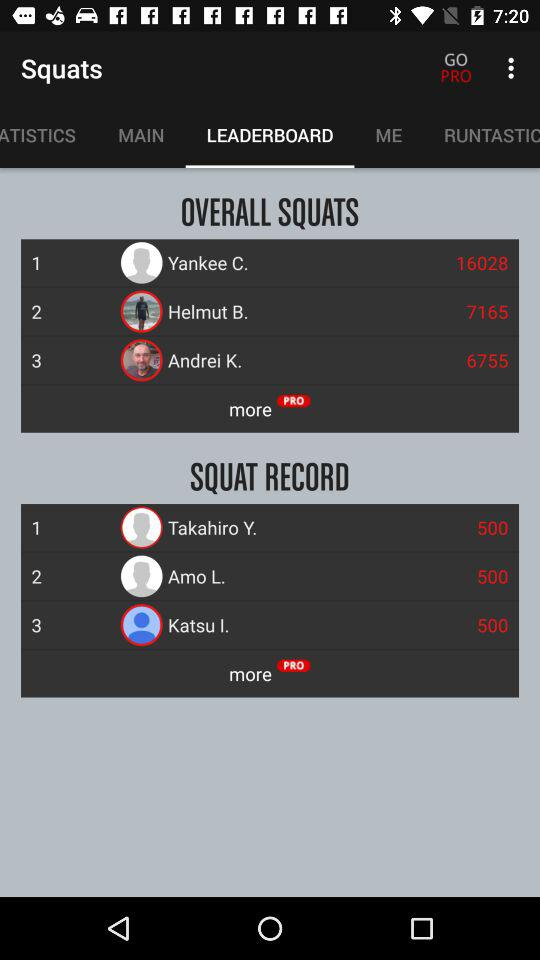Which player has the overall squats of 6755? The player who has the overall squats of 6755 is Andrei K. 